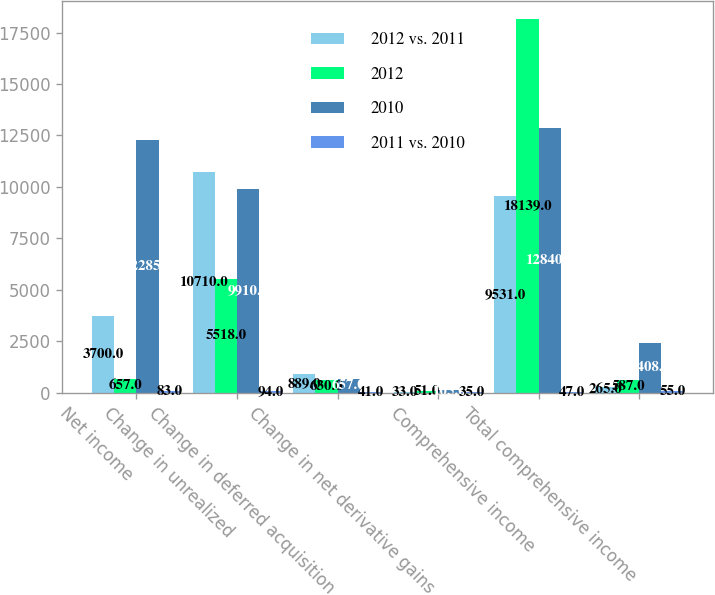Convert chart to OTSL. <chart><loc_0><loc_0><loc_500><loc_500><stacked_bar_chart><ecel><fcel>Net income<fcel>Change in unrealized<fcel>Change in deferred acquisition<fcel>Change in net derivative gains<fcel>Comprehensive income<fcel>Total comprehensive income<nl><fcel>2012 vs. 2011<fcel>3700<fcel>10710<fcel>889<fcel>33<fcel>9531<fcel>265<nl><fcel>2012<fcel>657<fcel>5518<fcel>630<fcel>51<fcel>18139<fcel>587<nl><fcel>2010<fcel>12285<fcel>9910<fcel>657<fcel>105<fcel>12840<fcel>2408<nl><fcel>2011 vs. 2010<fcel>83<fcel>94<fcel>41<fcel>35<fcel>47<fcel>55<nl></chart> 